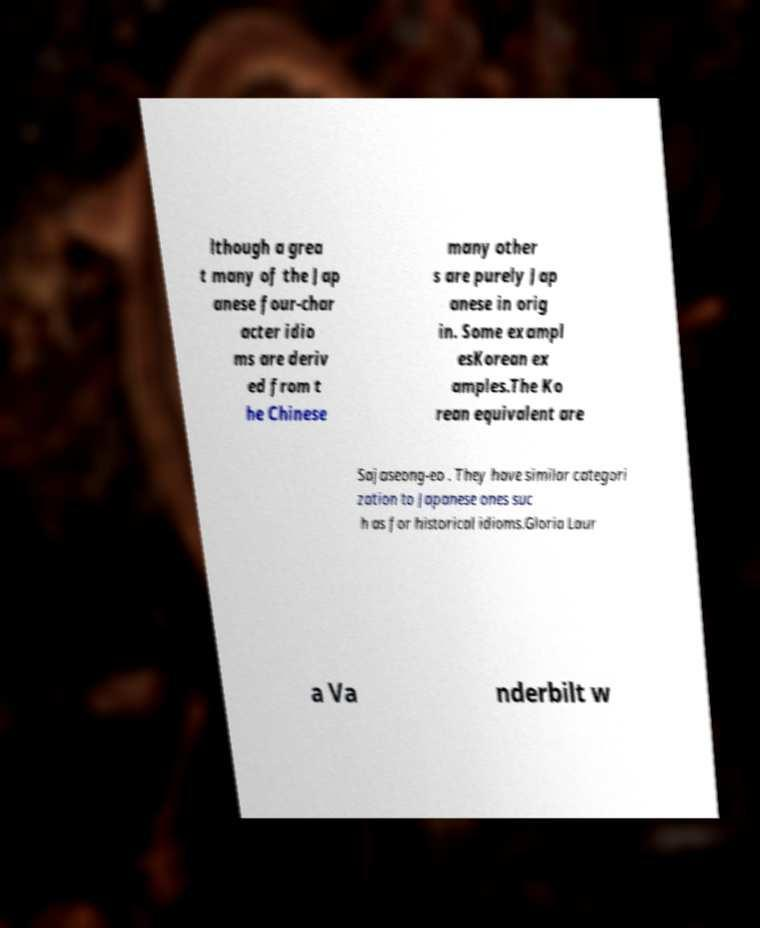Please identify and transcribe the text found in this image. lthough a grea t many of the Jap anese four-char acter idio ms are deriv ed from t he Chinese many other s are purely Jap anese in orig in. Some exampl esKorean ex amples.The Ko rean equivalent are Sajaseong-eo . They have similar categori zation to Japanese ones suc h as for historical idioms.Gloria Laur a Va nderbilt w 